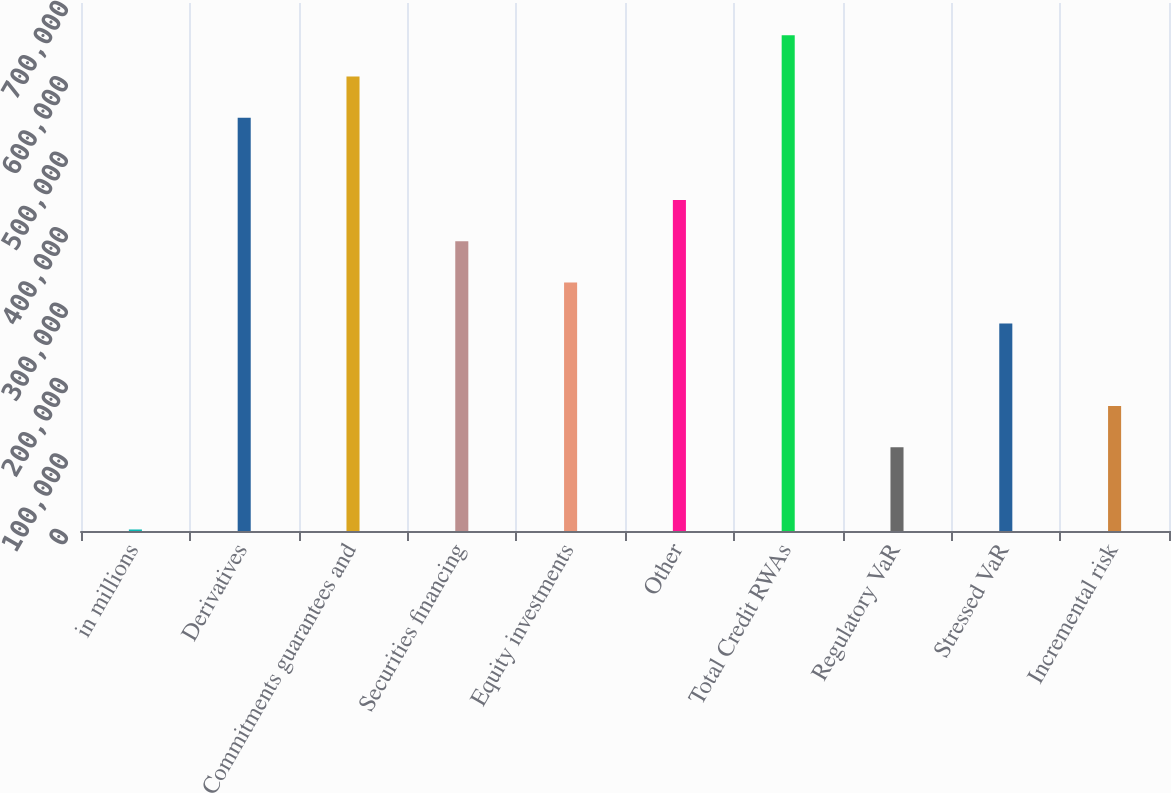Convert chart to OTSL. <chart><loc_0><loc_0><loc_500><loc_500><bar_chart><fcel>in millions<fcel>Derivatives<fcel>Commitments guarantees and<fcel>Securities financing<fcel>Equity investments<fcel>Other<fcel>Total Credit RWAs<fcel>Regulatory VaR<fcel>Stressed VaR<fcel>Incremental risk<nl><fcel>2018<fcel>547910<fcel>602499<fcel>384142<fcel>329553<fcel>438732<fcel>657088<fcel>111196<fcel>274964<fcel>165786<nl></chart> 